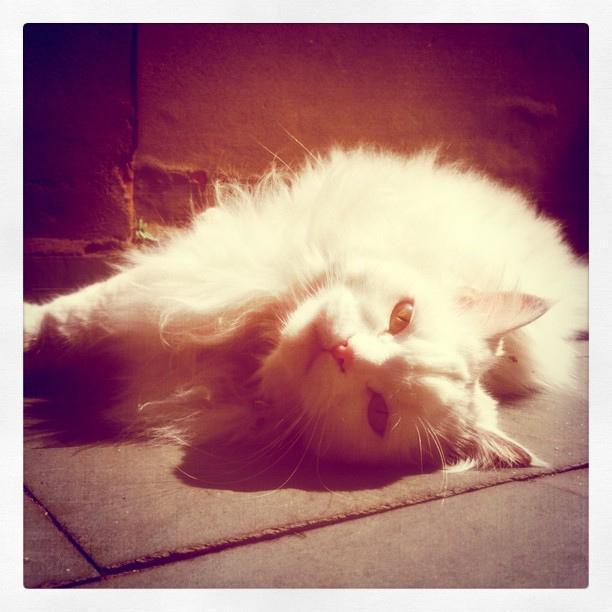How many baskets are on the left of the woman wearing stripes?
Give a very brief answer. 0. 